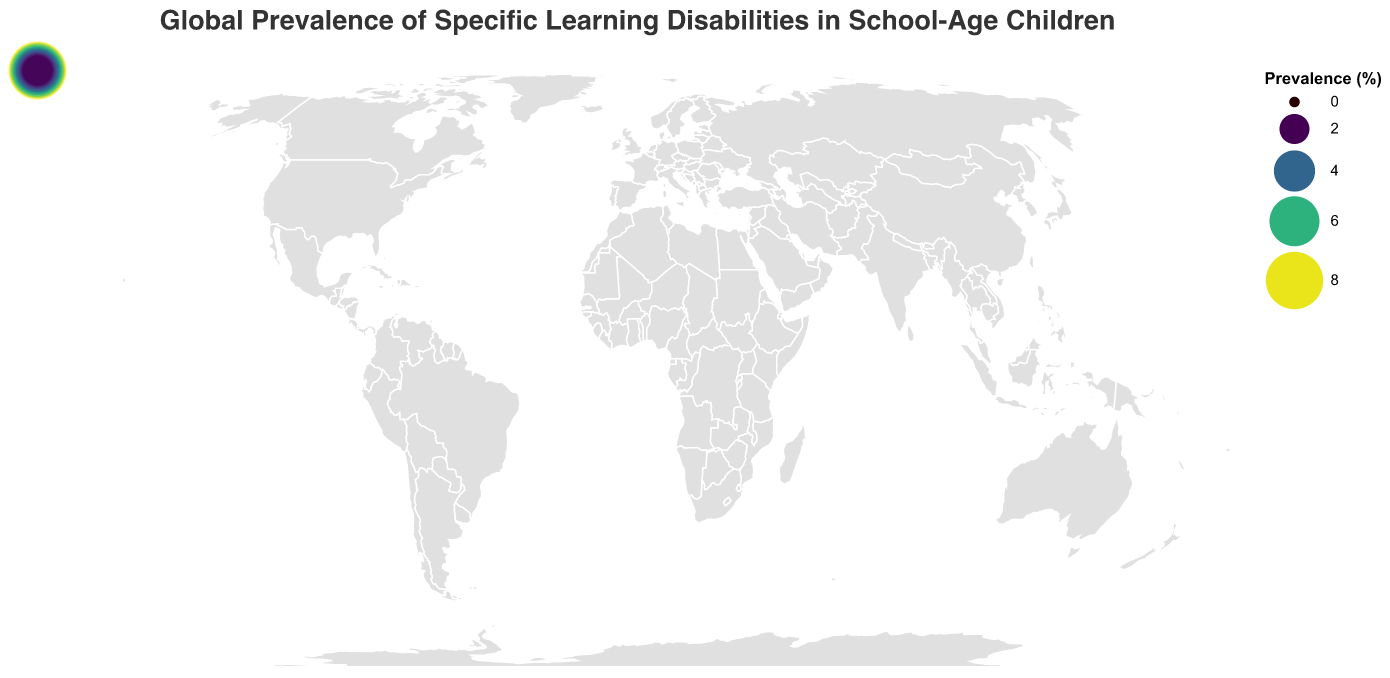What is the title of the figure? The title is at the top of the figure and usually provides a brief description of what the figure is about. In this case, it describes the content.
Answer: "Global Prevalence of Specific Learning Disabilities in School-Age Children" Which country has the highest prevalence of specific learning disabilities in school-age children? The countries are represented on the map with circles colored and sized according to their prevalence values. The largest circle denotes the highest prevalence.
Answer: The United States Which country has the lowest prevalence of specific learning disabilities in school-age children? The circles with the smallest size and lightest color represent the countries with the lowest prevalence. Turkey has the smallest circle.
Answer: Turkey What is the prevalence of specific learning disabilities in school-age children in the United Kingdom? Find the circle that corresponds to the United Kingdom; its tooltip will show the prevalence percentage.
Answer: 7.5% How does the prevalence in China compare to that in India? Locate the circles for China and India on the map and compare the prevalence values displayed in their tooltips.
Answer: China's prevalence (3.2%) is slightly higher than India's (3.0%) Calculate the average prevalence of specific learning disabilities in school-age children for all the countries listed. Sum the prevalence percentages for all the countries and divide by the total number of countries (20). The sum is 89.0, so the average is 89.0 / 20.
Answer: 4.45% What is the difference in prevalence between the country with the highest and the country with the lowest prevalence? Subtract the prevalence of the country with the lowest value (Turkey, 2.0%) from the highest value (United States, 8.2%).
Answer: 6.2% Which continent appears to have more countries with higher prevalence values? By looking at the map and interpreting the density of darker and larger circles, you can infer which continent has more higher-prevalence countries.
Answer: North America Are there any countries with a prevalence of specific learning disabilities above 5% but below 6%? If yes, name them. Examine the colour and size of circles to find countries within this specific range. The countries matching this criterion are Germany and Canada.
Answer: Canada and Germany What general trend can be observed about the prevalence of specific learning disabilities in school-age children across different countries? By observing the map, one can infer the trend of how prevalence changes geographically. Most generally observed is that highly developed countries like those in North America and Western Europe tend to have higher prevalence.
Answer: Higher prevalence in more developed countries 